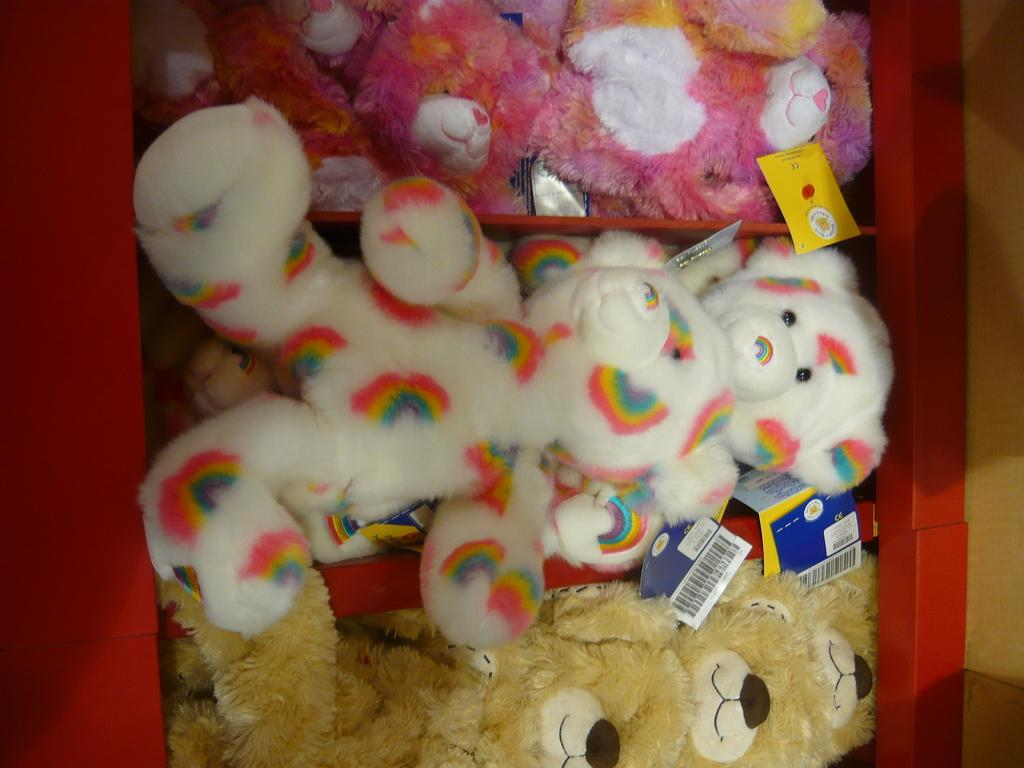What type of objects are in the shelves in the image? There are toys in the shelves in the image. Can you tell me how many heads of cabbage are on the shelves in the image? There is no cabbage present in the image; it features toys in the shelves. What type of weather condition is depicted in the image? There is no weather condition depicted in the image; it features toys in the shelves. 